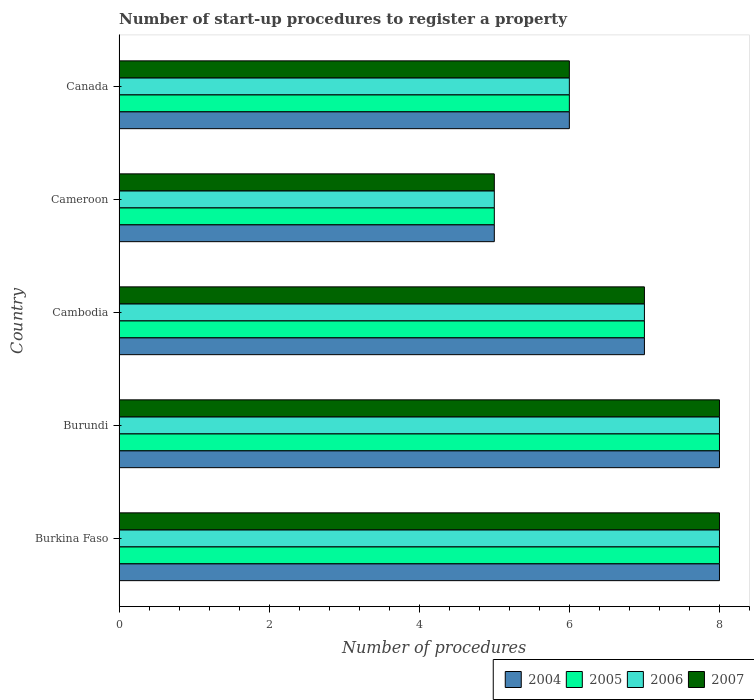How many groups of bars are there?
Your answer should be compact. 5. Are the number of bars per tick equal to the number of legend labels?
Keep it short and to the point. Yes. Are the number of bars on each tick of the Y-axis equal?
Your response must be concise. Yes. How many bars are there on the 1st tick from the bottom?
Offer a very short reply. 4. What is the label of the 4th group of bars from the top?
Your answer should be very brief. Burundi. In how many cases, is the number of bars for a given country not equal to the number of legend labels?
Your answer should be very brief. 0. What is the number of procedures required to register a property in 2005 in Canada?
Give a very brief answer. 6. Across all countries, what is the maximum number of procedures required to register a property in 2004?
Your answer should be very brief. 8. In which country was the number of procedures required to register a property in 2004 maximum?
Your answer should be compact. Burkina Faso. In which country was the number of procedures required to register a property in 2007 minimum?
Ensure brevity in your answer.  Cameroon. What is the total number of procedures required to register a property in 2005 in the graph?
Your response must be concise. 34. What is the difference between the number of procedures required to register a property in 2007 in Cambodia and the number of procedures required to register a property in 2004 in Cameroon?
Keep it short and to the point. 2. What is the difference between the number of procedures required to register a property in 2006 and number of procedures required to register a property in 2004 in Burundi?
Your answer should be very brief. 0. In how many countries, is the number of procedures required to register a property in 2007 greater than 6.8 ?
Ensure brevity in your answer.  3. What is the ratio of the number of procedures required to register a property in 2005 in Cambodia to that in Canada?
Provide a short and direct response. 1.17. Is the sum of the number of procedures required to register a property in 2007 in Cameroon and Canada greater than the maximum number of procedures required to register a property in 2006 across all countries?
Your answer should be compact. Yes. What does the 2nd bar from the top in Cameroon represents?
Offer a terse response. 2006. What does the 3rd bar from the bottom in Burundi represents?
Offer a very short reply. 2006. Is it the case that in every country, the sum of the number of procedures required to register a property in 2006 and number of procedures required to register a property in 2007 is greater than the number of procedures required to register a property in 2004?
Keep it short and to the point. Yes. How many bars are there?
Offer a very short reply. 20. How many countries are there in the graph?
Your response must be concise. 5. Where does the legend appear in the graph?
Keep it short and to the point. Bottom right. How many legend labels are there?
Keep it short and to the point. 4. What is the title of the graph?
Your response must be concise. Number of start-up procedures to register a property. What is the label or title of the X-axis?
Your answer should be compact. Number of procedures. What is the label or title of the Y-axis?
Keep it short and to the point. Country. What is the Number of procedures in 2007 in Burkina Faso?
Ensure brevity in your answer.  8. What is the Number of procedures of 2006 in Burundi?
Provide a short and direct response. 8. What is the Number of procedures of 2005 in Cambodia?
Your answer should be very brief. 7. What is the Number of procedures in 2006 in Cambodia?
Offer a very short reply. 7. What is the Number of procedures of 2004 in Canada?
Give a very brief answer. 6. What is the Number of procedures in 2005 in Canada?
Ensure brevity in your answer.  6. What is the Number of procedures in 2007 in Canada?
Your answer should be compact. 6. Across all countries, what is the maximum Number of procedures in 2007?
Offer a very short reply. 8. Across all countries, what is the minimum Number of procedures in 2004?
Provide a succinct answer. 5. Across all countries, what is the minimum Number of procedures in 2006?
Your response must be concise. 5. What is the total Number of procedures of 2004 in the graph?
Provide a succinct answer. 34. What is the total Number of procedures of 2005 in the graph?
Provide a short and direct response. 34. What is the total Number of procedures of 2007 in the graph?
Provide a short and direct response. 34. What is the difference between the Number of procedures of 2004 in Burkina Faso and that in Burundi?
Provide a short and direct response. 0. What is the difference between the Number of procedures of 2004 in Burkina Faso and that in Cambodia?
Give a very brief answer. 1. What is the difference between the Number of procedures of 2004 in Burkina Faso and that in Cameroon?
Your answer should be compact. 3. What is the difference between the Number of procedures of 2005 in Burkina Faso and that in Cameroon?
Provide a short and direct response. 3. What is the difference between the Number of procedures of 2006 in Burkina Faso and that in Cameroon?
Your answer should be very brief. 3. What is the difference between the Number of procedures of 2007 in Burkina Faso and that in Cameroon?
Provide a succinct answer. 3. What is the difference between the Number of procedures of 2006 in Burkina Faso and that in Canada?
Offer a very short reply. 2. What is the difference between the Number of procedures in 2006 in Burundi and that in Cambodia?
Ensure brevity in your answer.  1. What is the difference between the Number of procedures of 2007 in Burundi and that in Cambodia?
Ensure brevity in your answer.  1. What is the difference between the Number of procedures in 2004 in Burundi and that in Cameroon?
Provide a short and direct response. 3. What is the difference between the Number of procedures of 2005 in Burundi and that in Cameroon?
Offer a terse response. 3. What is the difference between the Number of procedures in 2007 in Burundi and that in Cameroon?
Provide a short and direct response. 3. What is the difference between the Number of procedures in 2004 in Cambodia and that in Cameroon?
Your response must be concise. 2. What is the difference between the Number of procedures in 2007 in Cambodia and that in Cameroon?
Provide a short and direct response. 2. What is the difference between the Number of procedures of 2004 in Cambodia and that in Canada?
Keep it short and to the point. 1. What is the difference between the Number of procedures of 2005 in Cambodia and that in Canada?
Make the answer very short. 1. What is the difference between the Number of procedures in 2007 in Cambodia and that in Canada?
Provide a short and direct response. 1. What is the difference between the Number of procedures of 2004 in Cameroon and that in Canada?
Offer a terse response. -1. What is the difference between the Number of procedures of 2005 in Cameroon and that in Canada?
Offer a terse response. -1. What is the difference between the Number of procedures of 2004 in Burkina Faso and the Number of procedures of 2005 in Burundi?
Give a very brief answer. 0. What is the difference between the Number of procedures in 2005 in Burkina Faso and the Number of procedures in 2007 in Burundi?
Give a very brief answer. 0. What is the difference between the Number of procedures of 2004 in Burkina Faso and the Number of procedures of 2005 in Cambodia?
Keep it short and to the point. 1. What is the difference between the Number of procedures in 2004 in Burkina Faso and the Number of procedures in 2006 in Cambodia?
Ensure brevity in your answer.  1. What is the difference between the Number of procedures in 2005 in Burkina Faso and the Number of procedures in 2006 in Cambodia?
Ensure brevity in your answer.  1. What is the difference between the Number of procedures in 2006 in Burkina Faso and the Number of procedures in 2007 in Cambodia?
Offer a very short reply. 1. What is the difference between the Number of procedures in 2004 in Burkina Faso and the Number of procedures in 2006 in Canada?
Offer a terse response. 2. What is the difference between the Number of procedures in 2004 in Burkina Faso and the Number of procedures in 2007 in Canada?
Give a very brief answer. 2. What is the difference between the Number of procedures in 2005 in Burkina Faso and the Number of procedures in 2007 in Canada?
Your response must be concise. 2. What is the difference between the Number of procedures of 2006 in Burkina Faso and the Number of procedures of 2007 in Canada?
Your response must be concise. 2. What is the difference between the Number of procedures of 2004 in Burundi and the Number of procedures of 2005 in Cambodia?
Make the answer very short. 1. What is the difference between the Number of procedures in 2004 in Burundi and the Number of procedures in 2006 in Cameroon?
Make the answer very short. 3. What is the difference between the Number of procedures of 2004 in Burundi and the Number of procedures of 2007 in Cameroon?
Provide a short and direct response. 3. What is the difference between the Number of procedures in 2005 in Burundi and the Number of procedures in 2006 in Cameroon?
Your response must be concise. 3. What is the difference between the Number of procedures in 2005 in Burundi and the Number of procedures in 2007 in Canada?
Your answer should be compact. 2. What is the difference between the Number of procedures of 2006 in Burundi and the Number of procedures of 2007 in Canada?
Give a very brief answer. 2. What is the difference between the Number of procedures in 2004 in Cambodia and the Number of procedures in 2005 in Cameroon?
Give a very brief answer. 2. What is the difference between the Number of procedures of 2006 in Cambodia and the Number of procedures of 2007 in Cameroon?
Offer a very short reply. 2. What is the difference between the Number of procedures in 2004 in Cambodia and the Number of procedures in 2005 in Canada?
Your response must be concise. 1. What is the difference between the Number of procedures in 2005 in Cambodia and the Number of procedures in 2006 in Canada?
Offer a terse response. 1. What is the difference between the Number of procedures of 2006 in Cambodia and the Number of procedures of 2007 in Canada?
Your response must be concise. 1. What is the difference between the Number of procedures of 2004 in Cameroon and the Number of procedures of 2005 in Canada?
Offer a terse response. -1. What is the difference between the Number of procedures of 2004 in Cameroon and the Number of procedures of 2006 in Canada?
Your answer should be compact. -1. What is the difference between the Number of procedures in 2005 in Cameroon and the Number of procedures in 2006 in Canada?
Your answer should be very brief. -1. What is the average Number of procedures in 2004 per country?
Your answer should be compact. 6.8. What is the difference between the Number of procedures of 2004 and Number of procedures of 2007 in Burkina Faso?
Keep it short and to the point. 0. What is the difference between the Number of procedures of 2004 and Number of procedures of 2006 in Burundi?
Your answer should be compact. 0. What is the difference between the Number of procedures in 2006 and Number of procedures in 2007 in Burundi?
Provide a short and direct response. 0. What is the difference between the Number of procedures in 2004 and Number of procedures in 2005 in Cambodia?
Offer a terse response. 0. What is the difference between the Number of procedures of 2005 and Number of procedures of 2006 in Cambodia?
Provide a short and direct response. 0. What is the difference between the Number of procedures in 2006 and Number of procedures in 2007 in Cambodia?
Offer a very short reply. 0. What is the difference between the Number of procedures of 2004 and Number of procedures of 2005 in Cameroon?
Provide a short and direct response. 0. What is the difference between the Number of procedures of 2004 and Number of procedures of 2006 in Cameroon?
Keep it short and to the point. 0. What is the difference between the Number of procedures in 2004 and Number of procedures in 2007 in Cameroon?
Ensure brevity in your answer.  0. What is the difference between the Number of procedures of 2005 and Number of procedures of 2006 in Cameroon?
Make the answer very short. 0. What is the difference between the Number of procedures of 2005 and Number of procedures of 2007 in Cameroon?
Make the answer very short. 0. What is the difference between the Number of procedures in 2006 and Number of procedures in 2007 in Cameroon?
Provide a short and direct response. 0. What is the difference between the Number of procedures of 2004 and Number of procedures of 2005 in Canada?
Provide a short and direct response. 0. What is the difference between the Number of procedures in 2004 and Number of procedures in 2006 in Canada?
Make the answer very short. 0. What is the difference between the Number of procedures of 2004 and Number of procedures of 2007 in Canada?
Provide a succinct answer. 0. What is the difference between the Number of procedures in 2006 and Number of procedures in 2007 in Canada?
Provide a succinct answer. 0. What is the ratio of the Number of procedures in 2004 in Burkina Faso to that in Burundi?
Your answer should be compact. 1. What is the ratio of the Number of procedures of 2005 in Burkina Faso to that in Burundi?
Give a very brief answer. 1. What is the ratio of the Number of procedures in 2006 in Burkina Faso to that in Burundi?
Give a very brief answer. 1. What is the ratio of the Number of procedures of 2007 in Burkina Faso to that in Burundi?
Provide a short and direct response. 1. What is the ratio of the Number of procedures in 2004 in Burkina Faso to that in Cambodia?
Offer a very short reply. 1.14. What is the ratio of the Number of procedures in 2007 in Burkina Faso to that in Cambodia?
Make the answer very short. 1.14. What is the ratio of the Number of procedures in 2005 in Burkina Faso to that in Cameroon?
Your answer should be very brief. 1.6. What is the ratio of the Number of procedures of 2007 in Burkina Faso to that in Cameroon?
Keep it short and to the point. 1.6. What is the ratio of the Number of procedures of 2005 in Burkina Faso to that in Canada?
Provide a succinct answer. 1.33. What is the ratio of the Number of procedures in 2004 in Burundi to that in Cambodia?
Provide a succinct answer. 1.14. What is the ratio of the Number of procedures of 2005 in Burundi to that in Cameroon?
Your answer should be very brief. 1.6. What is the ratio of the Number of procedures in 2006 in Burundi to that in Cameroon?
Make the answer very short. 1.6. What is the ratio of the Number of procedures of 2006 in Burundi to that in Canada?
Provide a succinct answer. 1.33. What is the ratio of the Number of procedures of 2007 in Burundi to that in Canada?
Provide a succinct answer. 1.33. What is the ratio of the Number of procedures of 2004 in Cambodia to that in Cameroon?
Make the answer very short. 1.4. What is the ratio of the Number of procedures in 2004 in Cambodia to that in Canada?
Provide a short and direct response. 1.17. What is the ratio of the Number of procedures of 2006 in Cambodia to that in Canada?
Your response must be concise. 1.17. What is the ratio of the Number of procedures of 2004 in Cameroon to that in Canada?
Your response must be concise. 0.83. What is the ratio of the Number of procedures of 2006 in Cameroon to that in Canada?
Offer a terse response. 0.83. What is the ratio of the Number of procedures in 2007 in Cameroon to that in Canada?
Keep it short and to the point. 0.83. What is the difference between the highest and the second highest Number of procedures of 2005?
Your answer should be very brief. 0. What is the difference between the highest and the second highest Number of procedures of 2007?
Your response must be concise. 0. 